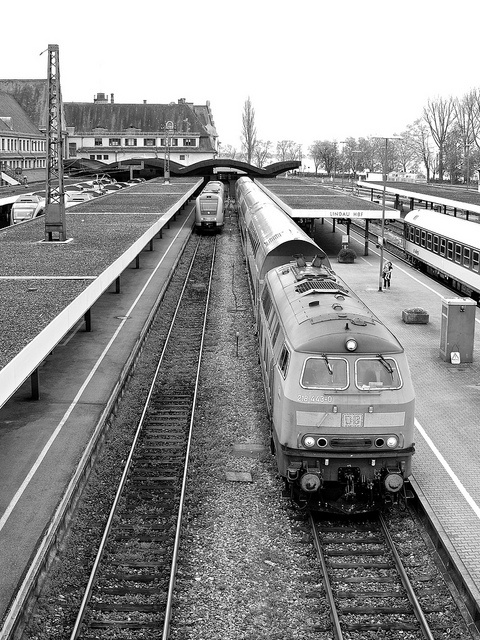Describe the objects in this image and their specific colors. I can see train in white, darkgray, black, lightgray, and gray tones, train in white, black, gray, and darkgray tones, train in white, darkgray, gray, lightgray, and black tones, people in darkgray, gray, and white tones, and people in white, black, darkgray, gray, and lightgray tones in this image. 